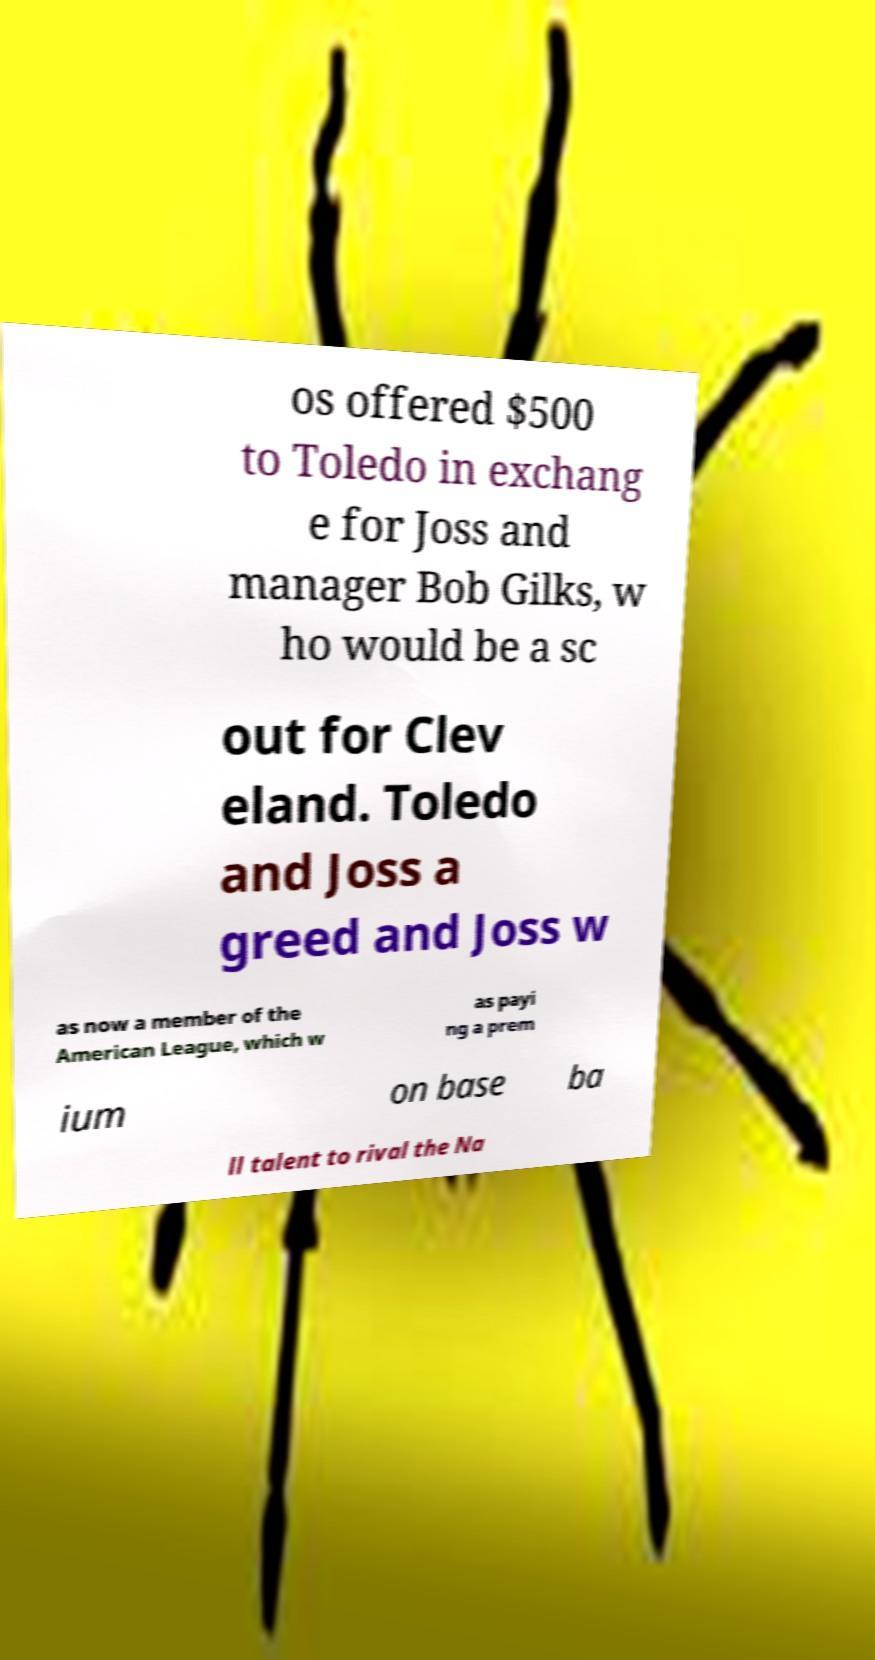Could you extract and type out the text from this image? os offered $500 to Toledo in exchang e for Joss and manager Bob Gilks, w ho would be a sc out for Clev eland. Toledo and Joss a greed and Joss w as now a member of the American League, which w as payi ng a prem ium on base ba ll talent to rival the Na 